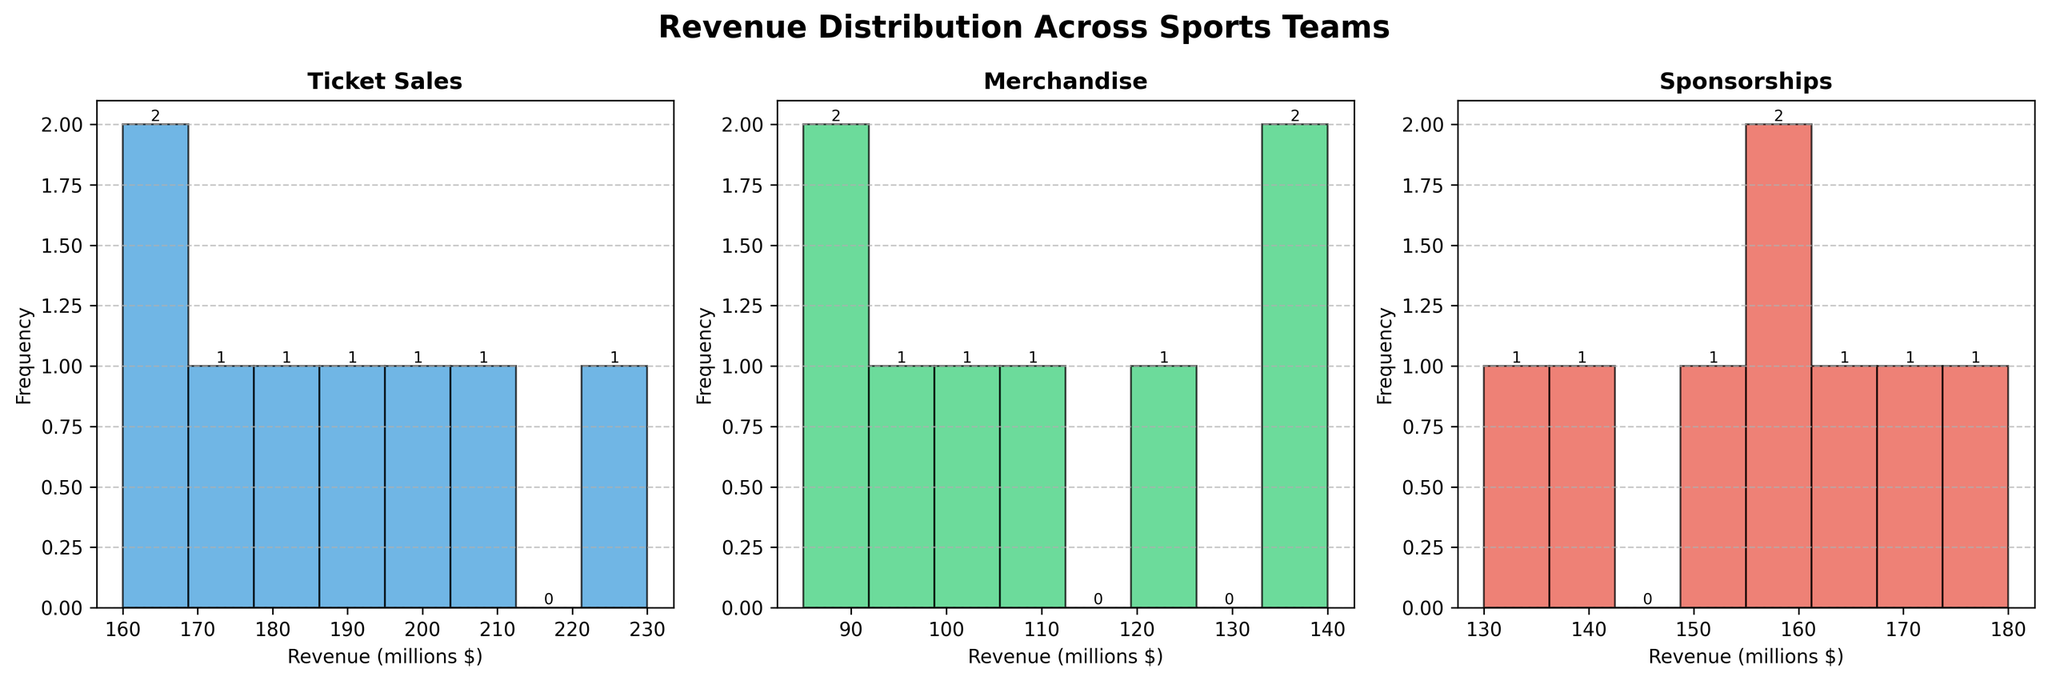What is the title of the figure? The title of the figure is shown at the top center of the plot and indicates the main topic of the visualization.
Answer: Revenue Distribution Across Sports Teams How many subplots are there in the figure? The figure is divided into three vertical sections, each representing a different revenue category for the sports teams.
Answer: 3 Which revenue category has the highest frequency of occurrences in the highest bin? By observing the histograms, we see the bin with the highest frequency of incidents. The "Ticket Sales" category displays this.
Answer: Ticket Sales What is the bin range with the highest frequency in the "Sponsorships" category? Looking at the histogram for "Sponsorships," the bin with the highest bar indicates the range of revenue values with the highest frequency.
Answer: 150-170 Compare the range of revenues shown in the "Ticket Sales" histogram with those in the "Merchandise" histogram. The "Ticket Sales" histogram ranges from 160 to 230 whereas the "Merchandise" histogram ranges from 85 to 140.
Answer: 160-230 vs. 85-140 Which category has the most evenly distributed revenue? A category with relatively uniform bar heights indicates an even distribution across different revenue bins.
Answer: Merchandise What is the total frequency count for the "Merchandise" category? Summing the heights of all the bars in the "Merchandise" histogram yields the total frequency count.
Answer: 8 Which category displays the widest variation in revenue amounts? The "Ticket Sales" histogram shows the widest spread from the lowest to highest revenue values, indicating the greatest variation.
Answer: Ticket Sales Does the "Sponsorships" histogram show any revenue values exceeding 180 million? By examining the histogram for "Sponsorships," we can see that none of the bins exceed 180 million.
Answer: No Are there any overlapping revenue ranges across different categories evident in the histograms? By comparing the horizontal axes of all three histograms, we can ascertain which revenue ranges appear in multiple categories.
Answer: Yes 